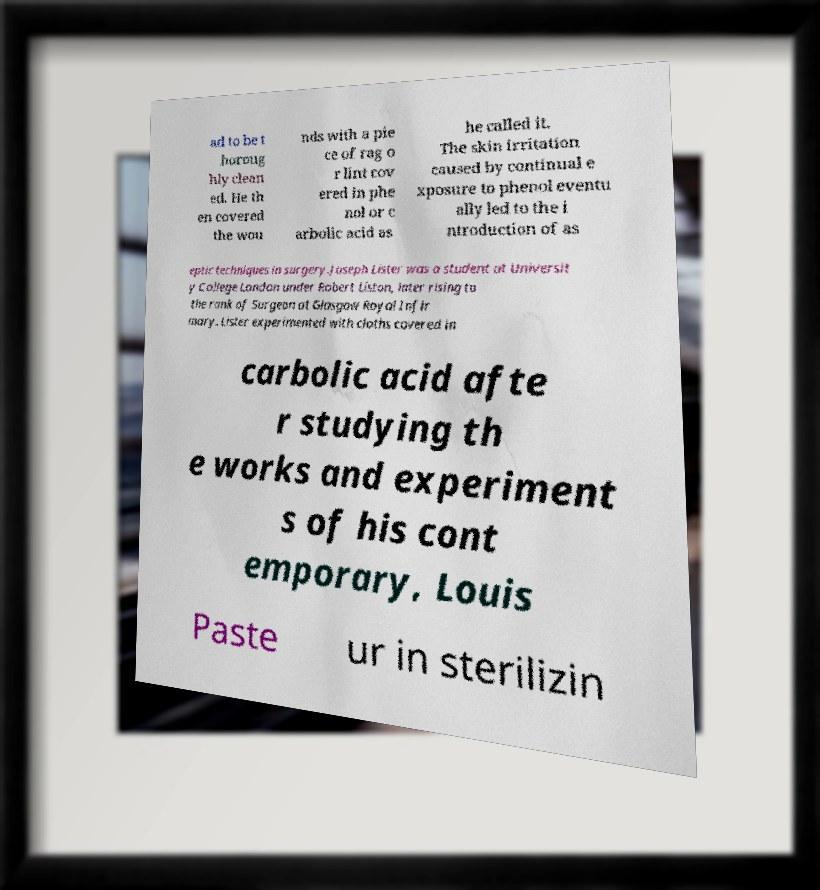Please read and relay the text visible in this image. What does it say? ad to be t horoug hly clean ed. He th en covered the wou nds with a pie ce of rag o r lint cov ered in phe nol or c arbolic acid as he called it. The skin irritation caused by continual e xposure to phenol eventu ally led to the i ntroduction of as eptic techniques in surgery.Joseph Lister was a student at Universit y College London under Robert Liston, later rising to the rank of Surgeon at Glasgow Royal Infir mary. Lister experimented with cloths covered in carbolic acid afte r studying th e works and experiment s of his cont emporary, Louis Paste ur in sterilizin 